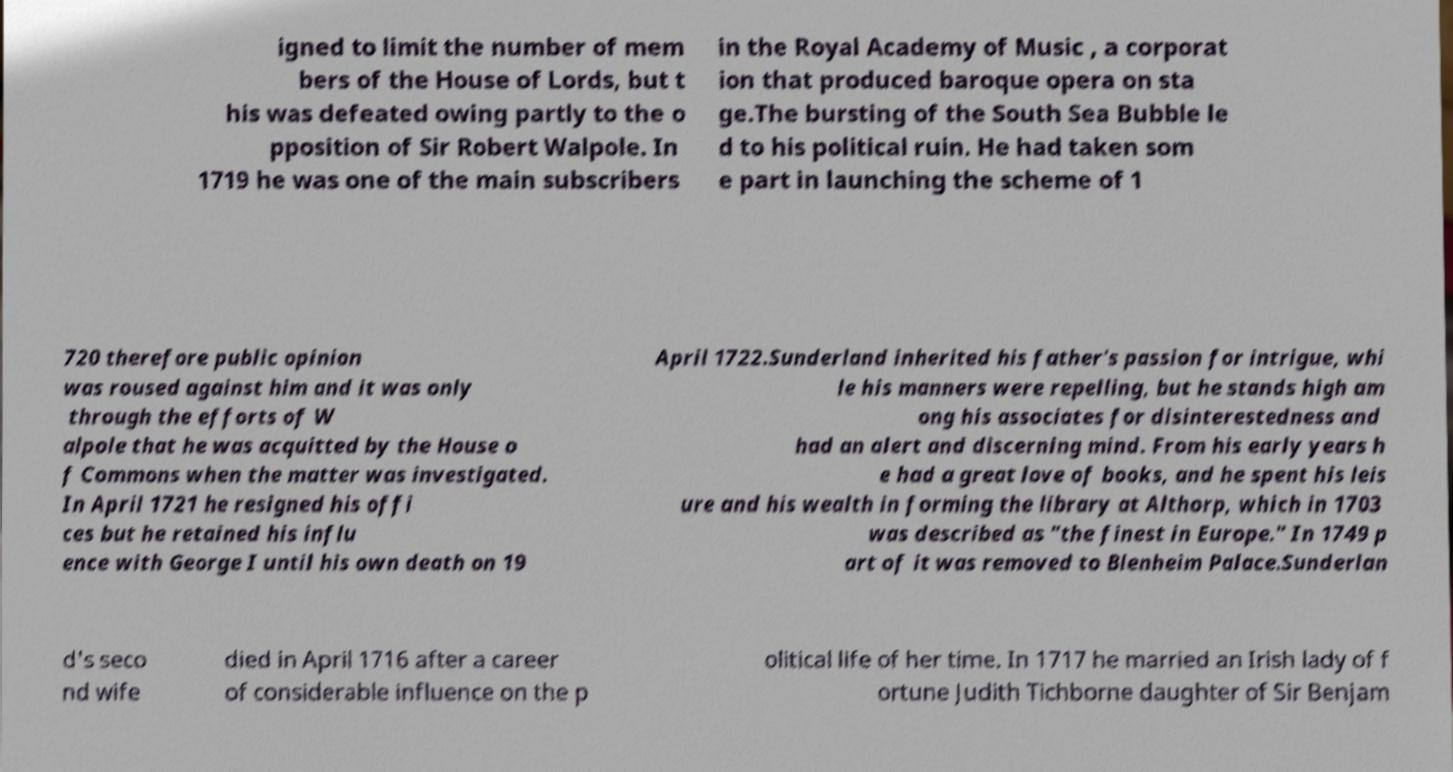For documentation purposes, I need the text within this image transcribed. Could you provide that? igned to limit the number of mem bers of the House of Lords, but t his was defeated owing partly to the o pposition of Sir Robert Walpole. In 1719 he was one of the main subscribers in the Royal Academy of Music , a corporat ion that produced baroque opera on sta ge.The bursting of the South Sea Bubble le d to his political ruin. He had taken som e part in launching the scheme of 1 720 therefore public opinion was roused against him and it was only through the efforts of W alpole that he was acquitted by the House o f Commons when the matter was investigated. In April 1721 he resigned his offi ces but he retained his influ ence with George I until his own death on 19 April 1722.Sunderland inherited his father's passion for intrigue, whi le his manners were repelling, but he stands high am ong his associates for disinterestedness and had an alert and discerning mind. From his early years h e had a great love of books, and he spent his leis ure and his wealth in forming the library at Althorp, which in 1703 was described as "the finest in Europe." In 1749 p art of it was removed to Blenheim Palace.Sunderlan d's seco nd wife died in April 1716 after a career of considerable influence on the p olitical life of her time. In 1717 he married an Irish lady of f ortune Judith Tichborne daughter of Sir Benjam 